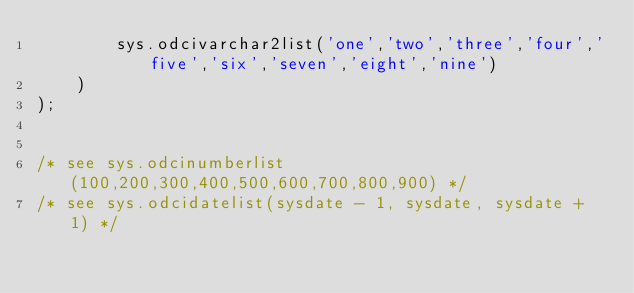<code> <loc_0><loc_0><loc_500><loc_500><_SQL_>		sys.odcivarchar2list('one','two','three','four','five','six','seven','eight','nine')
	)
);


/* see sys.odcinumberlist(100,200,300,400,500,600,700,800,900) */
/* see sys.odcidatelist(sysdate - 1, sysdate, sysdate + 1) */</code> 